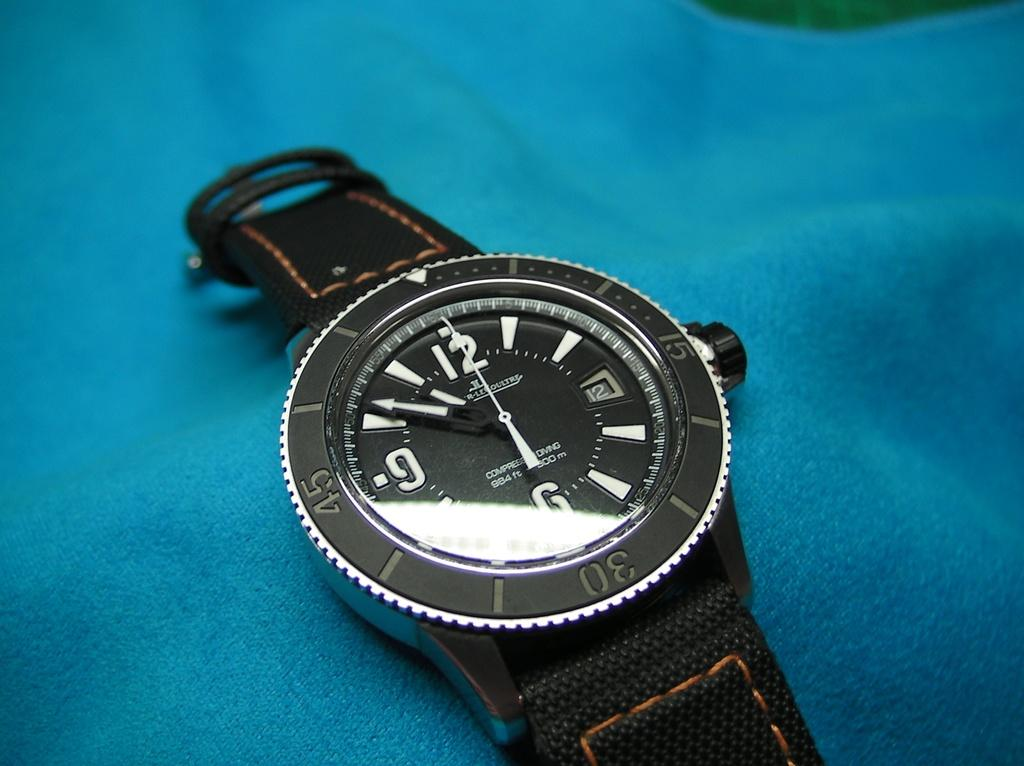<image>
Offer a succinct explanation of the picture presented. The watch has a 6 a 9 and a 12 timer. 